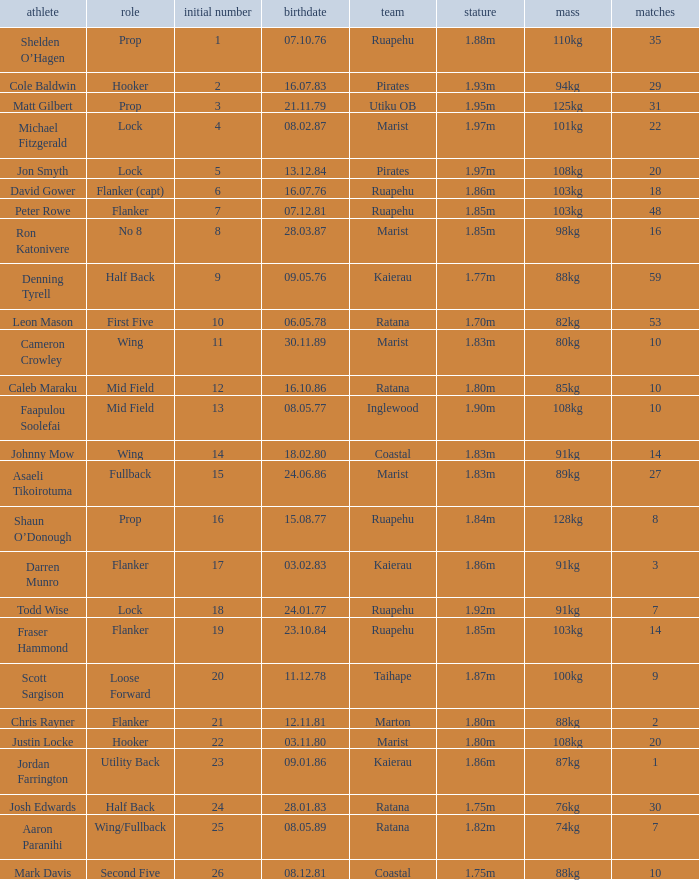Which player weighs 76kg? Josh Edwards. 